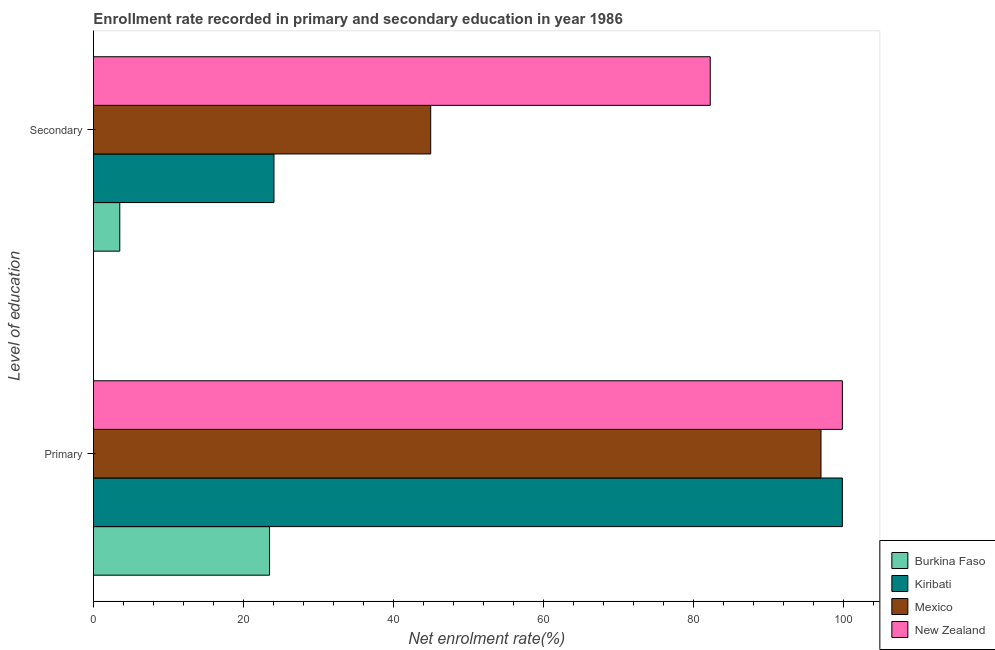How many different coloured bars are there?
Ensure brevity in your answer.  4. Are the number of bars per tick equal to the number of legend labels?
Make the answer very short. Yes. What is the label of the 2nd group of bars from the top?
Offer a very short reply. Primary. What is the enrollment rate in secondary education in Burkina Faso?
Give a very brief answer. 3.51. Across all countries, what is the maximum enrollment rate in secondary education?
Your response must be concise. 82.26. Across all countries, what is the minimum enrollment rate in secondary education?
Keep it short and to the point. 3.51. In which country was the enrollment rate in primary education maximum?
Your response must be concise. Kiribati. In which country was the enrollment rate in secondary education minimum?
Ensure brevity in your answer.  Burkina Faso. What is the total enrollment rate in secondary education in the graph?
Make the answer very short. 154.83. What is the difference between the enrollment rate in primary education in Mexico and that in Burkina Faso?
Ensure brevity in your answer.  73.55. What is the difference between the enrollment rate in primary education in New Zealand and the enrollment rate in secondary education in Mexico?
Your response must be concise. 54.91. What is the average enrollment rate in primary education per country?
Provide a succinct answer. 80.07. What is the difference between the enrollment rate in secondary education and enrollment rate in primary education in Mexico?
Give a very brief answer. -52.06. In how many countries, is the enrollment rate in secondary education greater than 60 %?
Provide a succinct answer. 1. What is the ratio of the enrollment rate in secondary education in Kiribati to that in Burkina Faso?
Offer a terse response. 6.86. Is the enrollment rate in secondary education in Burkina Faso less than that in Kiribati?
Provide a succinct answer. Yes. What does the 3rd bar from the top in Primary represents?
Offer a very short reply. Kiribati. Are all the bars in the graph horizontal?
Give a very brief answer. Yes. What is the difference between two consecutive major ticks on the X-axis?
Make the answer very short. 20. What is the title of the graph?
Give a very brief answer. Enrollment rate recorded in primary and secondary education in year 1986. What is the label or title of the X-axis?
Provide a short and direct response. Net enrolment rate(%). What is the label or title of the Y-axis?
Provide a succinct answer. Level of education. What is the Net enrolment rate(%) of Burkina Faso in Primary?
Ensure brevity in your answer.  23.49. What is the Net enrolment rate(%) in Kiribati in Primary?
Ensure brevity in your answer.  99.89. What is the Net enrolment rate(%) of Mexico in Primary?
Provide a succinct answer. 97.03. What is the Net enrolment rate(%) of New Zealand in Primary?
Your answer should be compact. 99.89. What is the Net enrolment rate(%) in Burkina Faso in Secondary?
Provide a short and direct response. 3.51. What is the Net enrolment rate(%) of Kiribati in Secondary?
Provide a succinct answer. 24.08. What is the Net enrolment rate(%) of Mexico in Secondary?
Your answer should be compact. 44.98. What is the Net enrolment rate(%) of New Zealand in Secondary?
Your answer should be very brief. 82.26. Across all Level of education, what is the maximum Net enrolment rate(%) in Burkina Faso?
Provide a short and direct response. 23.49. Across all Level of education, what is the maximum Net enrolment rate(%) in Kiribati?
Make the answer very short. 99.89. Across all Level of education, what is the maximum Net enrolment rate(%) of Mexico?
Make the answer very short. 97.03. Across all Level of education, what is the maximum Net enrolment rate(%) of New Zealand?
Offer a terse response. 99.89. Across all Level of education, what is the minimum Net enrolment rate(%) of Burkina Faso?
Give a very brief answer. 3.51. Across all Level of education, what is the minimum Net enrolment rate(%) in Kiribati?
Make the answer very short. 24.08. Across all Level of education, what is the minimum Net enrolment rate(%) of Mexico?
Your answer should be very brief. 44.98. Across all Level of education, what is the minimum Net enrolment rate(%) of New Zealand?
Make the answer very short. 82.26. What is the total Net enrolment rate(%) of Burkina Faso in the graph?
Provide a short and direct response. 27. What is the total Net enrolment rate(%) in Kiribati in the graph?
Offer a terse response. 123.96. What is the total Net enrolment rate(%) in Mexico in the graph?
Keep it short and to the point. 142.01. What is the total Net enrolment rate(%) of New Zealand in the graph?
Provide a short and direct response. 182.15. What is the difference between the Net enrolment rate(%) of Burkina Faso in Primary and that in Secondary?
Your response must be concise. 19.98. What is the difference between the Net enrolment rate(%) of Kiribati in Primary and that in Secondary?
Provide a succinct answer. 75.81. What is the difference between the Net enrolment rate(%) in Mexico in Primary and that in Secondary?
Offer a very short reply. 52.06. What is the difference between the Net enrolment rate(%) in New Zealand in Primary and that in Secondary?
Ensure brevity in your answer.  17.62. What is the difference between the Net enrolment rate(%) in Burkina Faso in Primary and the Net enrolment rate(%) in Kiribati in Secondary?
Make the answer very short. -0.59. What is the difference between the Net enrolment rate(%) of Burkina Faso in Primary and the Net enrolment rate(%) of Mexico in Secondary?
Give a very brief answer. -21.49. What is the difference between the Net enrolment rate(%) of Burkina Faso in Primary and the Net enrolment rate(%) of New Zealand in Secondary?
Give a very brief answer. -58.78. What is the difference between the Net enrolment rate(%) of Kiribati in Primary and the Net enrolment rate(%) of Mexico in Secondary?
Your response must be concise. 54.91. What is the difference between the Net enrolment rate(%) of Kiribati in Primary and the Net enrolment rate(%) of New Zealand in Secondary?
Give a very brief answer. 17.62. What is the difference between the Net enrolment rate(%) in Mexico in Primary and the Net enrolment rate(%) in New Zealand in Secondary?
Keep it short and to the point. 14.77. What is the average Net enrolment rate(%) of Burkina Faso per Level of education?
Make the answer very short. 13.5. What is the average Net enrolment rate(%) in Kiribati per Level of education?
Give a very brief answer. 61.98. What is the average Net enrolment rate(%) of Mexico per Level of education?
Provide a succinct answer. 71.01. What is the average Net enrolment rate(%) of New Zealand per Level of education?
Make the answer very short. 91.07. What is the difference between the Net enrolment rate(%) in Burkina Faso and Net enrolment rate(%) in Kiribati in Primary?
Give a very brief answer. -76.4. What is the difference between the Net enrolment rate(%) in Burkina Faso and Net enrolment rate(%) in Mexico in Primary?
Your response must be concise. -73.55. What is the difference between the Net enrolment rate(%) of Burkina Faso and Net enrolment rate(%) of New Zealand in Primary?
Your response must be concise. -76.4. What is the difference between the Net enrolment rate(%) in Kiribati and Net enrolment rate(%) in Mexico in Primary?
Keep it short and to the point. 2.85. What is the difference between the Net enrolment rate(%) in Kiribati and Net enrolment rate(%) in New Zealand in Primary?
Provide a short and direct response. 0. What is the difference between the Net enrolment rate(%) in Mexico and Net enrolment rate(%) in New Zealand in Primary?
Provide a short and direct response. -2.85. What is the difference between the Net enrolment rate(%) of Burkina Faso and Net enrolment rate(%) of Kiribati in Secondary?
Make the answer very short. -20.57. What is the difference between the Net enrolment rate(%) in Burkina Faso and Net enrolment rate(%) in Mexico in Secondary?
Your response must be concise. -41.47. What is the difference between the Net enrolment rate(%) in Burkina Faso and Net enrolment rate(%) in New Zealand in Secondary?
Offer a very short reply. -78.75. What is the difference between the Net enrolment rate(%) in Kiribati and Net enrolment rate(%) in Mexico in Secondary?
Provide a short and direct response. -20.9. What is the difference between the Net enrolment rate(%) in Kiribati and Net enrolment rate(%) in New Zealand in Secondary?
Offer a very short reply. -58.19. What is the difference between the Net enrolment rate(%) of Mexico and Net enrolment rate(%) of New Zealand in Secondary?
Offer a very short reply. -37.29. What is the ratio of the Net enrolment rate(%) in Burkina Faso in Primary to that in Secondary?
Your answer should be compact. 6.69. What is the ratio of the Net enrolment rate(%) of Kiribati in Primary to that in Secondary?
Your answer should be very brief. 4.15. What is the ratio of the Net enrolment rate(%) of Mexico in Primary to that in Secondary?
Give a very brief answer. 2.16. What is the ratio of the Net enrolment rate(%) of New Zealand in Primary to that in Secondary?
Your answer should be compact. 1.21. What is the difference between the highest and the second highest Net enrolment rate(%) in Burkina Faso?
Your answer should be very brief. 19.98. What is the difference between the highest and the second highest Net enrolment rate(%) of Kiribati?
Provide a short and direct response. 75.81. What is the difference between the highest and the second highest Net enrolment rate(%) of Mexico?
Your answer should be compact. 52.06. What is the difference between the highest and the second highest Net enrolment rate(%) in New Zealand?
Keep it short and to the point. 17.62. What is the difference between the highest and the lowest Net enrolment rate(%) in Burkina Faso?
Keep it short and to the point. 19.98. What is the difference between the highest and the lowest Net enrolment rate(%) of Kiribati?
Your answer should be very brief. 75.81. What is the difference between the highest and the lowest Net enrolment rate(%) in Mexico?
Provide a short and direct response. 52.06. What is the difference between the highest and the lowest Net enrolment rate(%) of New Zealand?
Your answer should be compact. 17.62. 